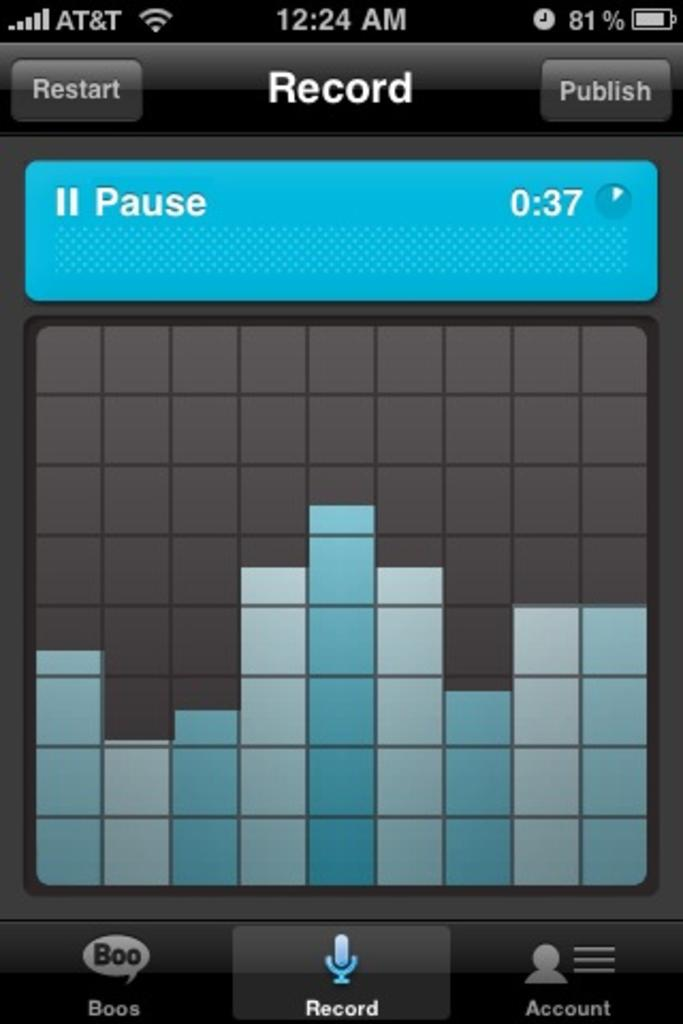<image>
Relay a brief, clear account of the picture shown. At 12:24am game has been paused at 0:37. 